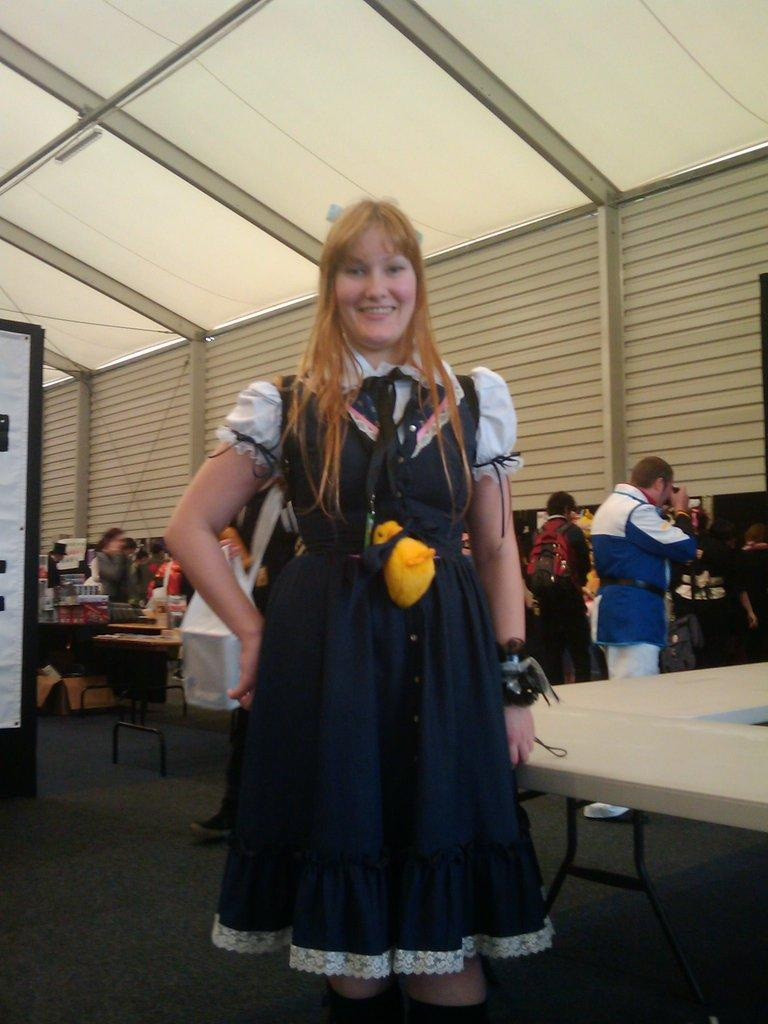What is the woman in the image doing? The woman is standing and smiling in the image. What can be seen in the background of the image? There is a wall and a roof visible in the image. Are there any other people in the image besides the woman? Yes, there are people standing in the image. What is the primary object in the foreground of the image? There is a table in the image. What type of comb is the woman using in the image? There is no comb present in the image. How many cakes are visible on the table in the image? There is no mention of cakes in the image; the primary object on the table is not specified. 